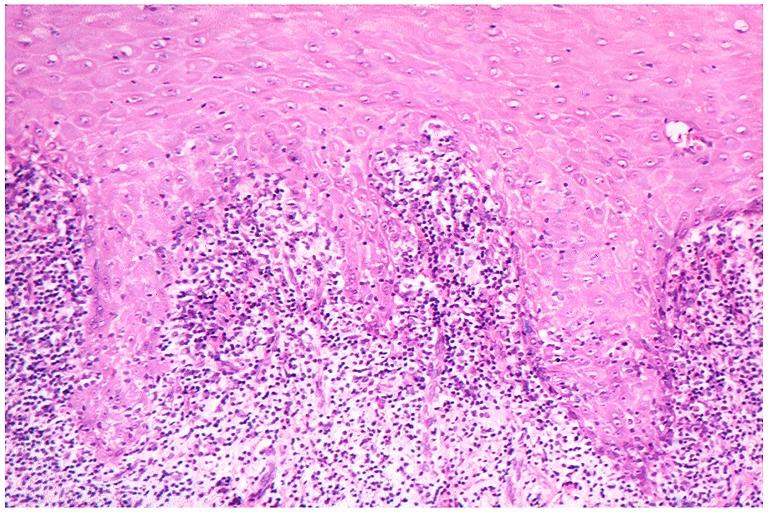where is this?
Answer the question using a single word or phrase. Oral 